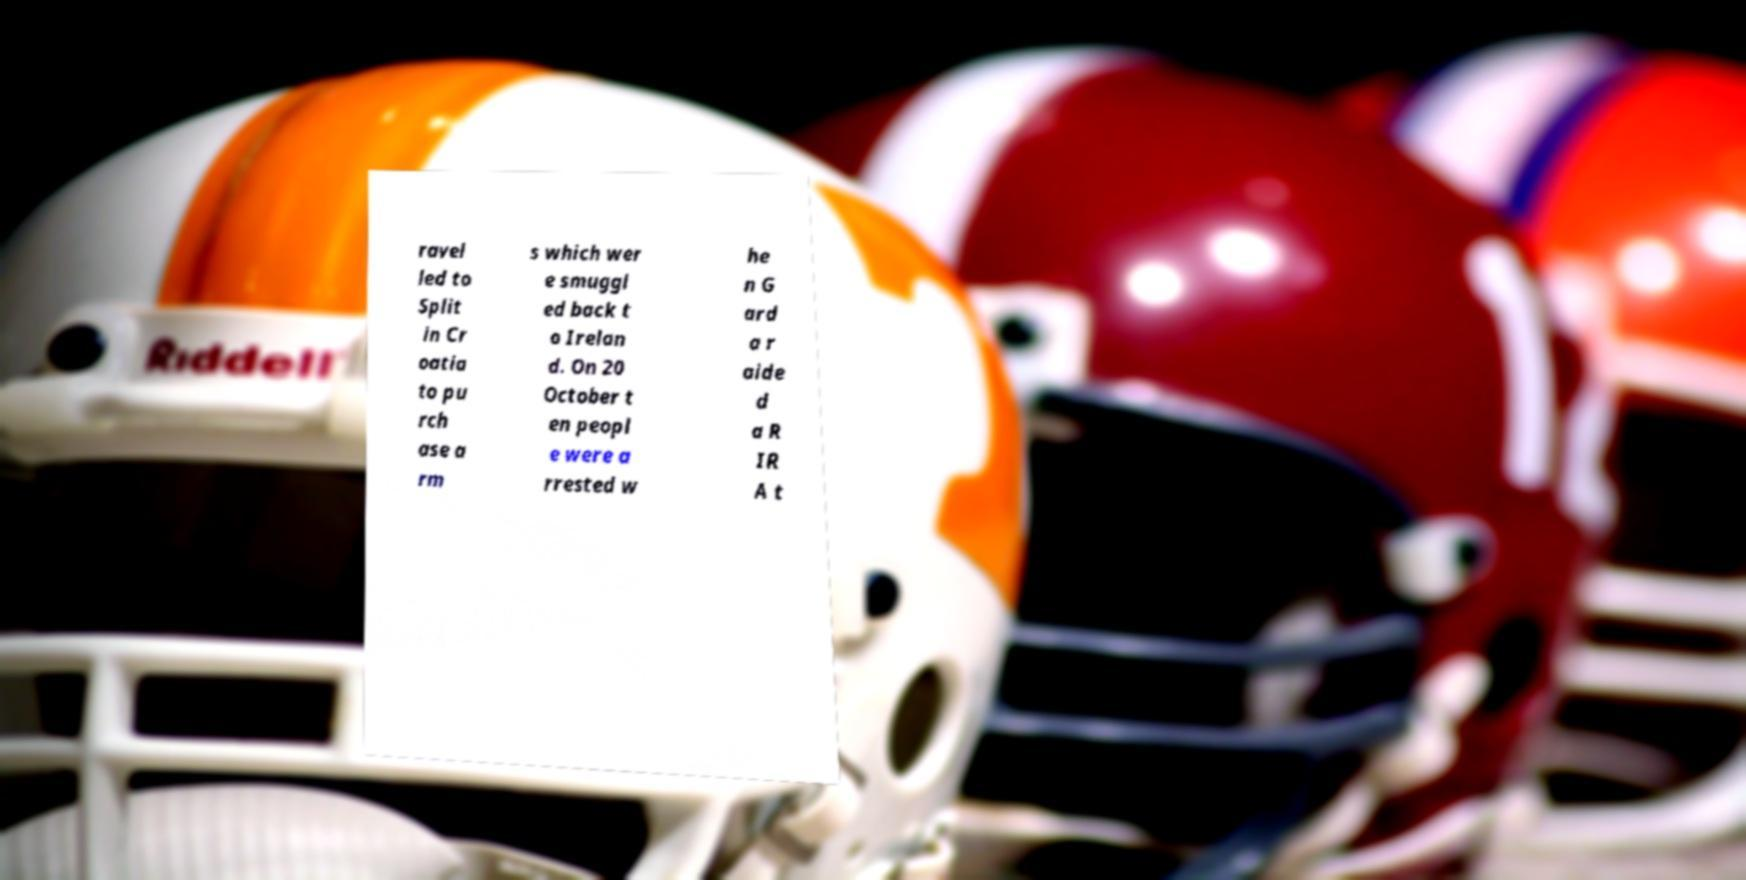For documentation purposes, I need the text within this image transcribed. Could you provide that? ravel led to Split in Cr oatia to pu rch ase a rm s which wer e smuggl ed back t o Irelan d. On 20 October t en peopl e were a rrested w he n G ard a r aide d a R IR A t 